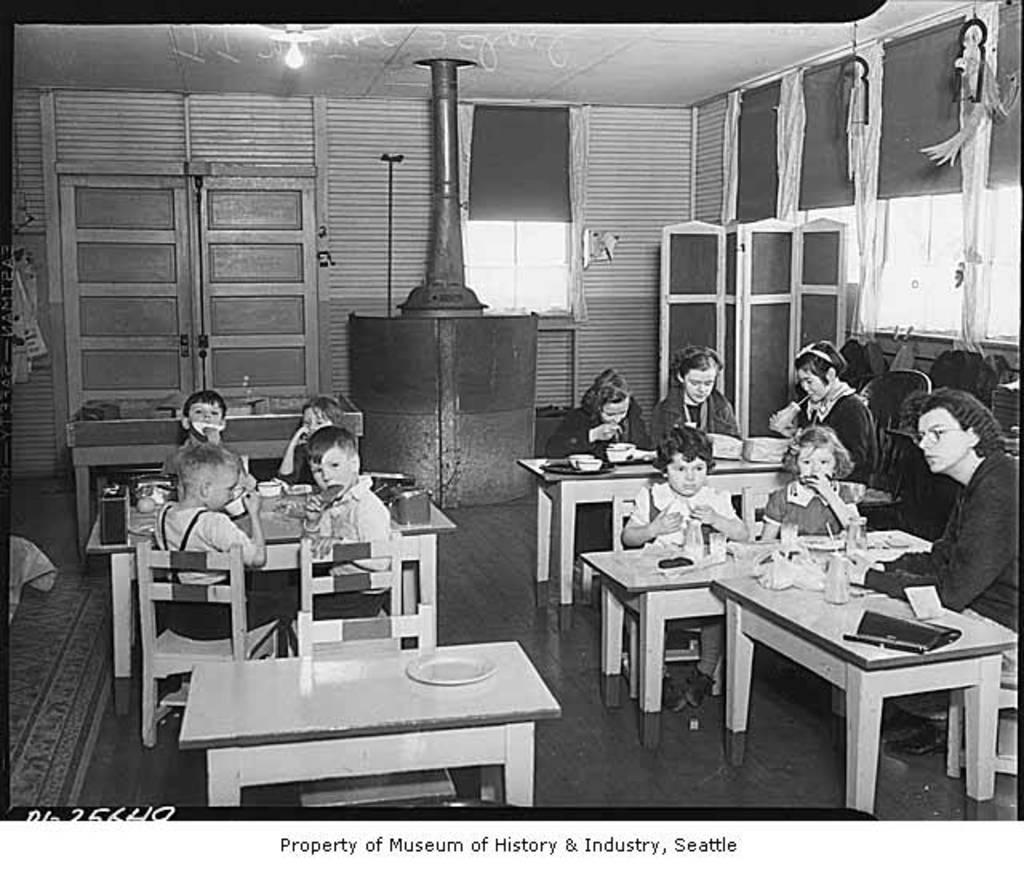What are the people in the image doing? The people in the image are seated on chairs. What objects are on the tables in the image? There are plates and bowls on the tables in the image. What can be found on the plates and bowls in the image? There are food items on the plates and bowls in the image. What type of nation is represented by the clam on the table in the image? There is no clam present in the image, so it is not possible to determine what nation it might represent. 